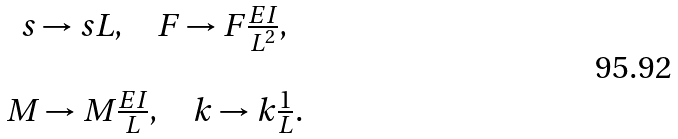<formula> <loc_0><loc_0><loc_500><loc_500>\begin{array} { c } s \rightarrow s L , \quad F \rightarrow { F } \frac { E I } { L ^ { 2 } } , \\ \\ { M } \rightarrow { M } \frac { E I } { L } , \quad k \rightarrow { k } \frac { 1 } { L } . \end{array}</formula> 